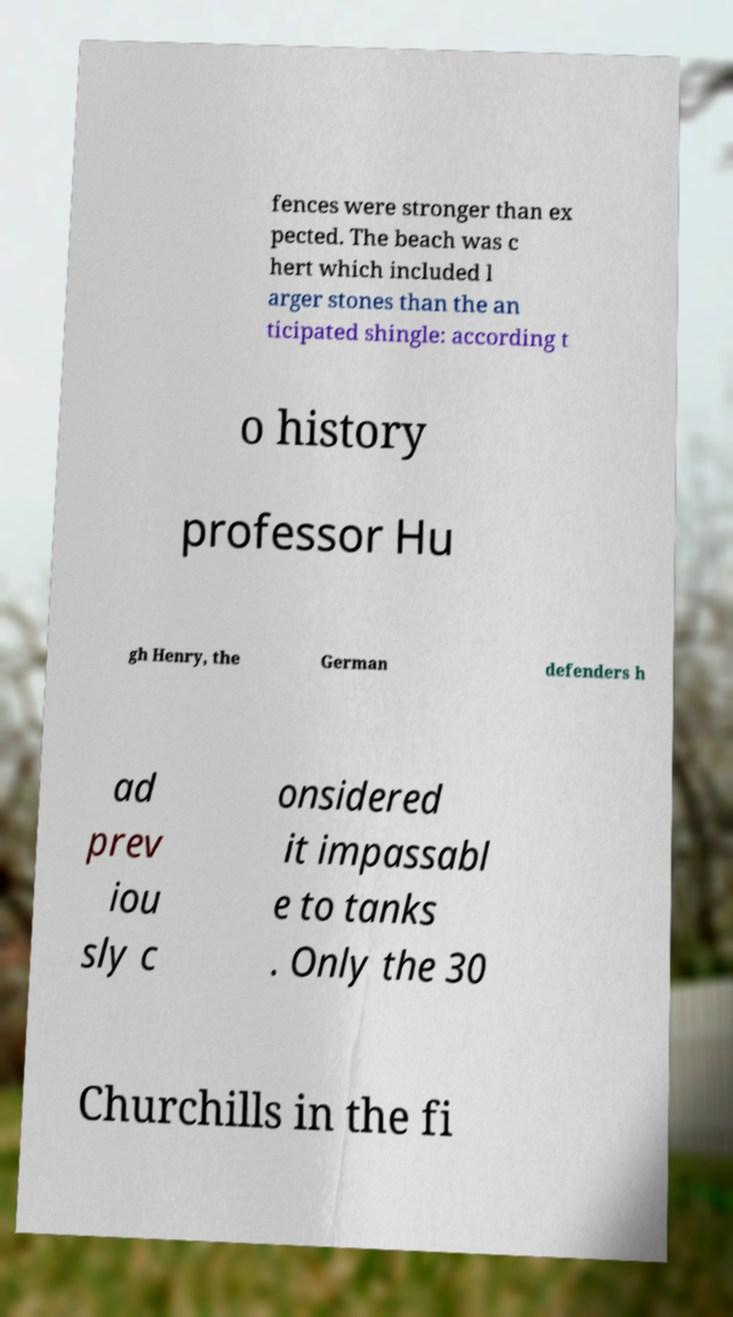What messages or text are displayed in this image? I need them in a readable, typed format. fences were stronger than ex pected. The beach was c hert which included l arger stones than the an ticipated shingle: according t o history professor Hu gh Henry, the German defenders h ad prev iou sly c onsidered it impassabl e to tanks . Only the 30 Churchills in the fi 